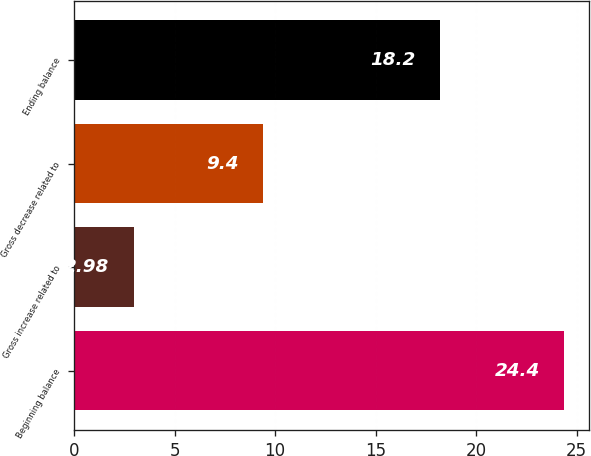<chart> <loc_0><loc_0><loc_500><loc_500><bar_chart><fcel>Beginning balance<fcel>Gross increase related to<fcel>Gross decrease related to<fcel>Ending balance<nl><fcel>24.4<fcel>2.98<fcel>9.4<fcel>18.2<nl></chart> 